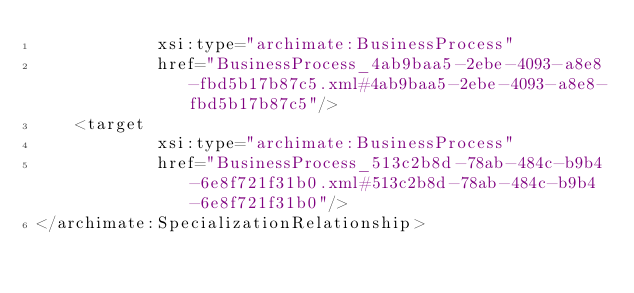Convert code to text. <code><loc_0><loc_0><loc_500><loc_500><_XML_>            xsi:type="archimate:BusinessProcess"
            href="BusinessProcess_4ab9baa5-2ebe-4093-a8e8-fbd5b17b87c5.xml#4ab9baa5-2ebe-4093-a8e8-fbd5b17b87c5"/>
    <target
            xsi:type="archimate:BusinessProcess"
            href="BusinessProcess_513c2b8d-78ab-484c-b9b4-6e8f721f31b0.xml#513c2b8d-78ab-484c-b9b4-6e8f721f31b0"/>
</archimate:SpecializationRelationship>
</code> 